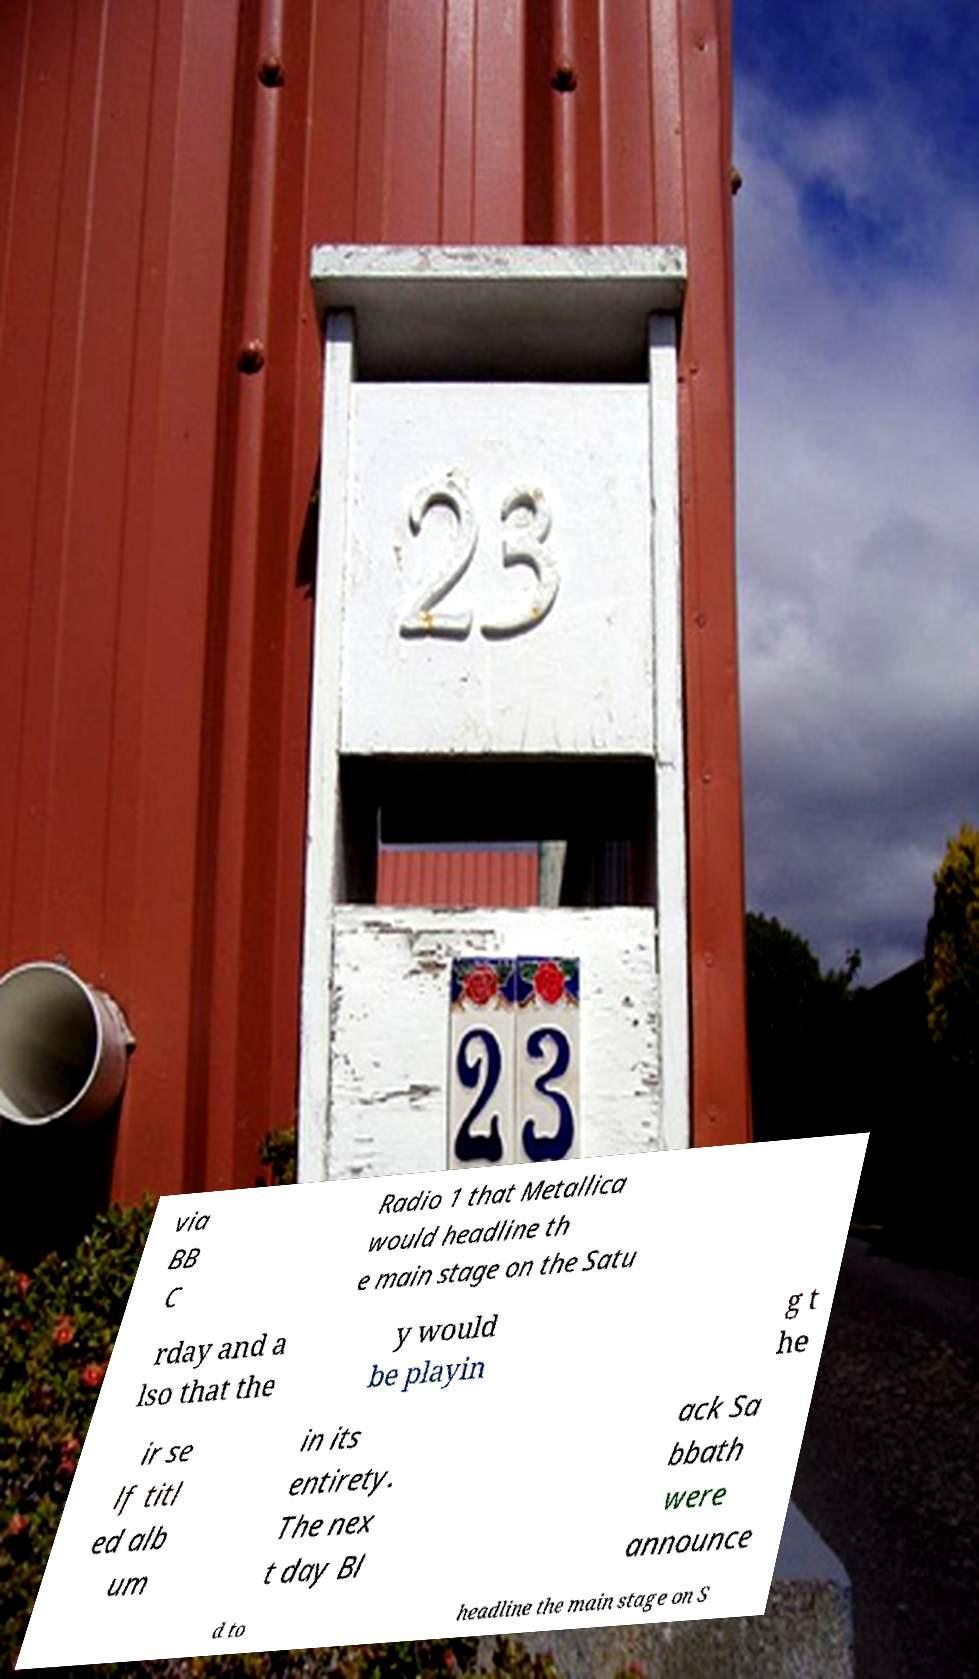What messages or text are displayed in this image? I need them in a readable, typed format. via BB C Radio 1 that Metallica would headline th e main stage on the Satu rday and a lso that the y would be playin g t he ir se lf titl ed alb um in its entirety. The nex t day Bl ack Sa bbath were announce d to headline the main stage on S 